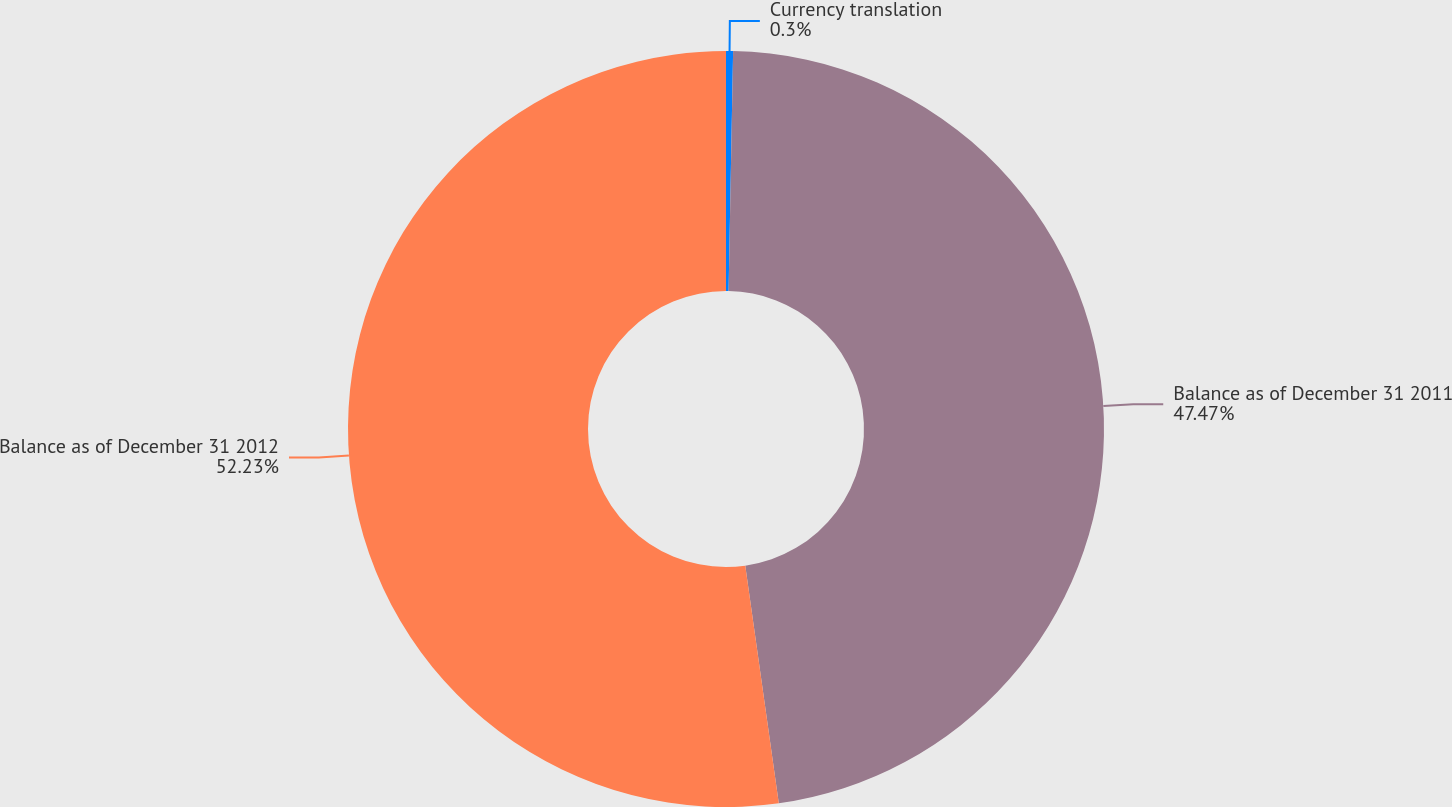Convert chart to OTSL. <chart><loc_0><loc_0><loc_500><loc_500><pie_chart><fcel>Currency translation<fcel>Balance as of December 31 2011<fcel>Balance as of December 31 2012<nl><fcel>0.3%<fcel>47.47%<fcel>52.23%<nl></chart> 